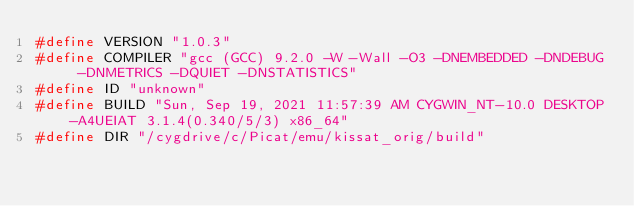<code> <loc_0><loc_0><loc_500><loc_500><_C_>#define VERSION "1.0.3"
#define COMPILER "gcc (GCC) 9.2.0 -W -Wall -O3 -DNEMBEDDED -DNDEBUG -DNMETRICS -DQUIET -DNSTATISTICS"
#define ID "unknown"
#define BUILD "Sun, Sep 19, 2021 11:57:39 AM CYGWIN_NT-10.0 DESKTOP-A4UEIAT 3.1.4(0.340/5/3) x86_64"
#define DIR "/cygdrive/c/Picat/emu/kissat_orig/build"
</code> 